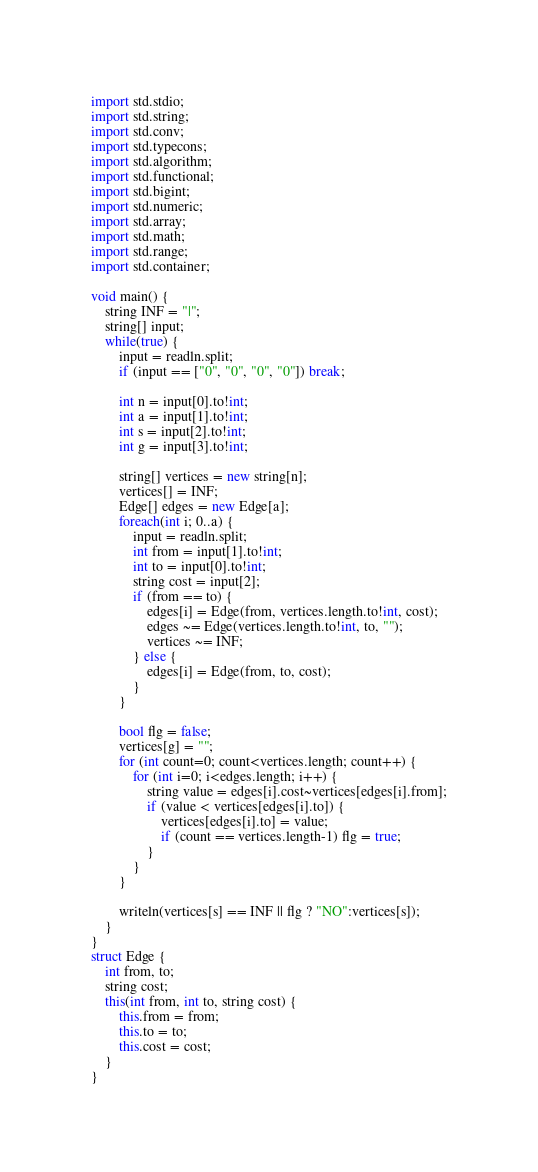Convert code to text. <code><loc_0><loc_0><loc_500><loc_500><_D_>import std.stdio;
import std.string;
import std.conv;
import std.typecons;
import std.algorithm;
import std.functional;
import std.bigint;
import std.numeric;
import std.array;
import std.math;
import std.range;
import std.container;

void main() {
    string INF = "|";
    string[] input;
    while(true) {
        input = readln.split;
        if (input == ["0", "0", "0", "0"]) break;

        int n = input[0].to!int;
        int a = input[1].to!int;
        int s = input[2].to!int;
        int g = input[3].to!int;

        string[] vertices = new string[n];
        vertices[] = INF;
        Edge[] edges = new Edge[a];
        foreach(int i; 0..a) {
            input = readln.split;
            int from = input[1].to!int;
            int to = input[0].to!int;
            string cost = input[2];
            if (from == to) {
                edges[i] = Edge(from, vertices.length.to!int, cost);
                edges ~= Edge(vertices.length.to!int, to, "");
                vertices ~= INF;
            } else {
                edges[i] = Edge(from, to, cost);
            }
        }

        bool flg = false;
        vertices[g] = "";
        for (int count=0; count<vertices.length; count++) {
            for (int i=0; i<edges.length; i++) {
                string value = edges[i].cost~vertices[edges[i].from];
                if (value < vertices[edges[i].to]) {
                    vertices[edges[i].to] = value;
                    if (count == vertices.length-1) flg = true;
                }
            }
        }

        writeln(vertices[s] == INF || flg ? "NO":vertices[s]);
    }
}
struct Edge {
    int from, to;
    string cost;
    this(int from, int to, string cost) {
        this.from = from;
        this.to = to;
        this.cost = cost;
    }
}</code> 